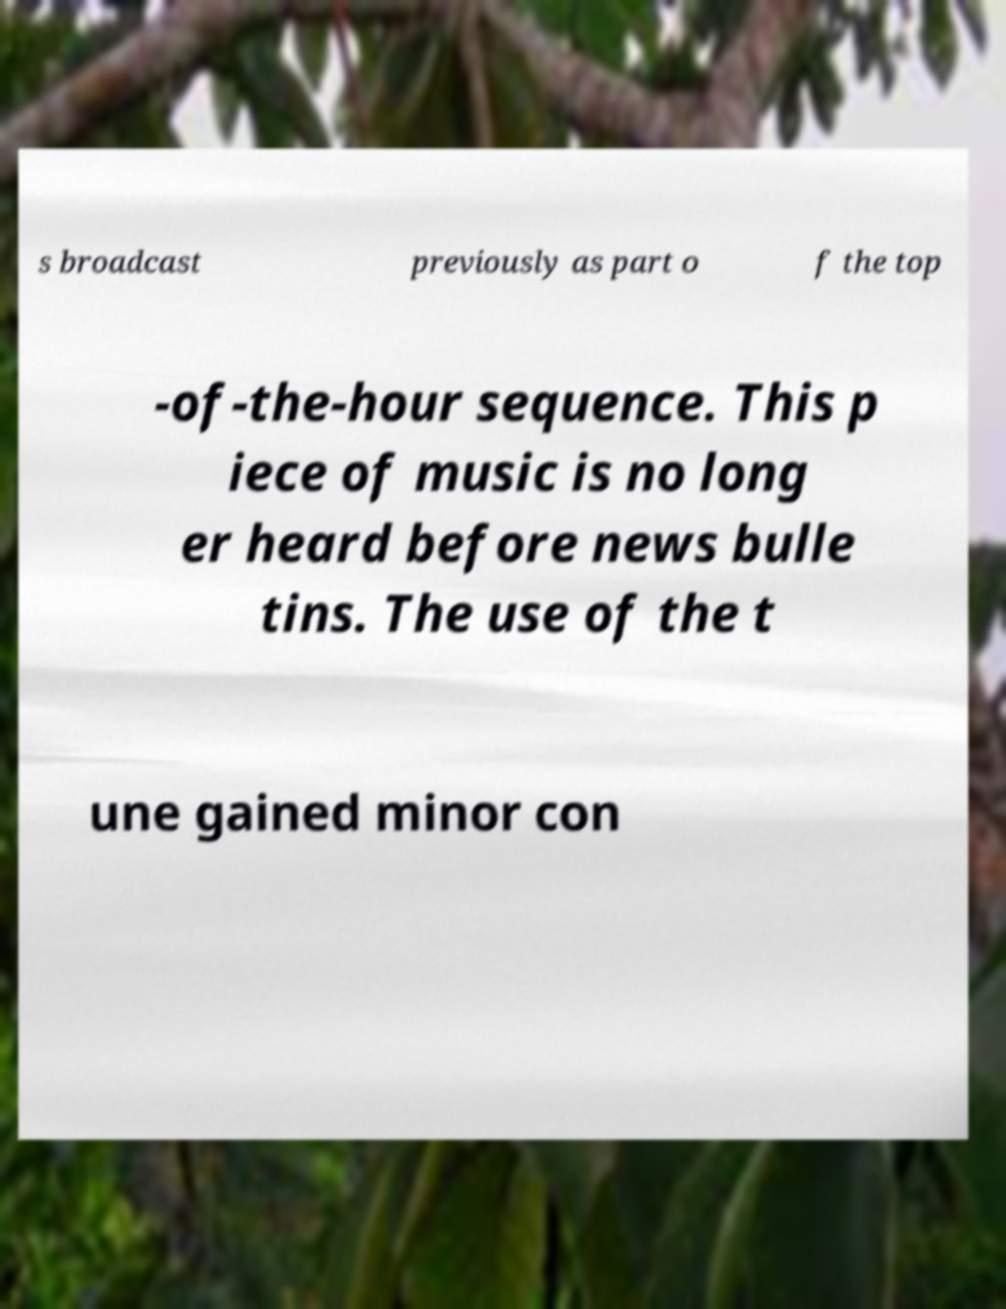There's text embedded in this image that I need extracted. Can you transcribe it verbatim? s broadcast previously as part o f the top -of-the-hour sequence. This p iece of music is no long er heard before news bulle tins. The use of the t une gained minor con 